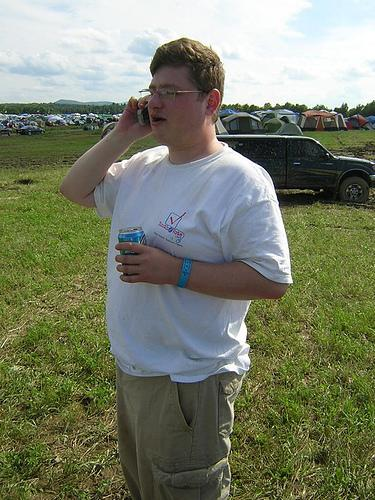Where will people located here sleep tonight? Please explain your reasoning. tents. We see a multitude of tents set up in the background. we can conclude many people at this event will be staying overnight in them. 